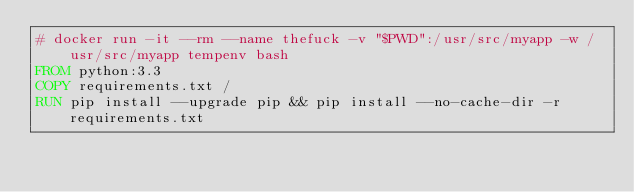Convert code to text. <code><loc_0><loc_0><loc_500><loc_500><_Dockerfile_># docker run -it --rm --name thefuck -v "$PWD":/usr/src/myapp -w /usr/src/myapp tempenv bash
FROM python:3.3
COPY requirements.txt /
RUN pip install --upgrade pip && pip install --no-cache-dir -r requirements.txt
</code> 